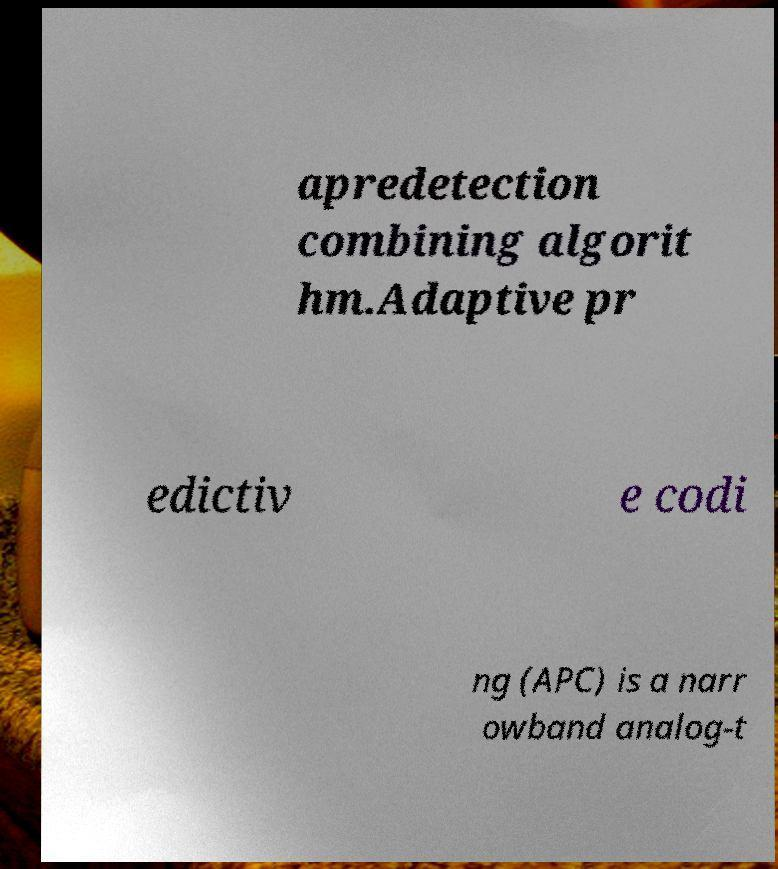Could you assist in decoding the text presented in this image and type it out clearly? apredetection combining algorit hm.Adaptive pr edictiv e codi ng (APC) is a narr owband analog-t 